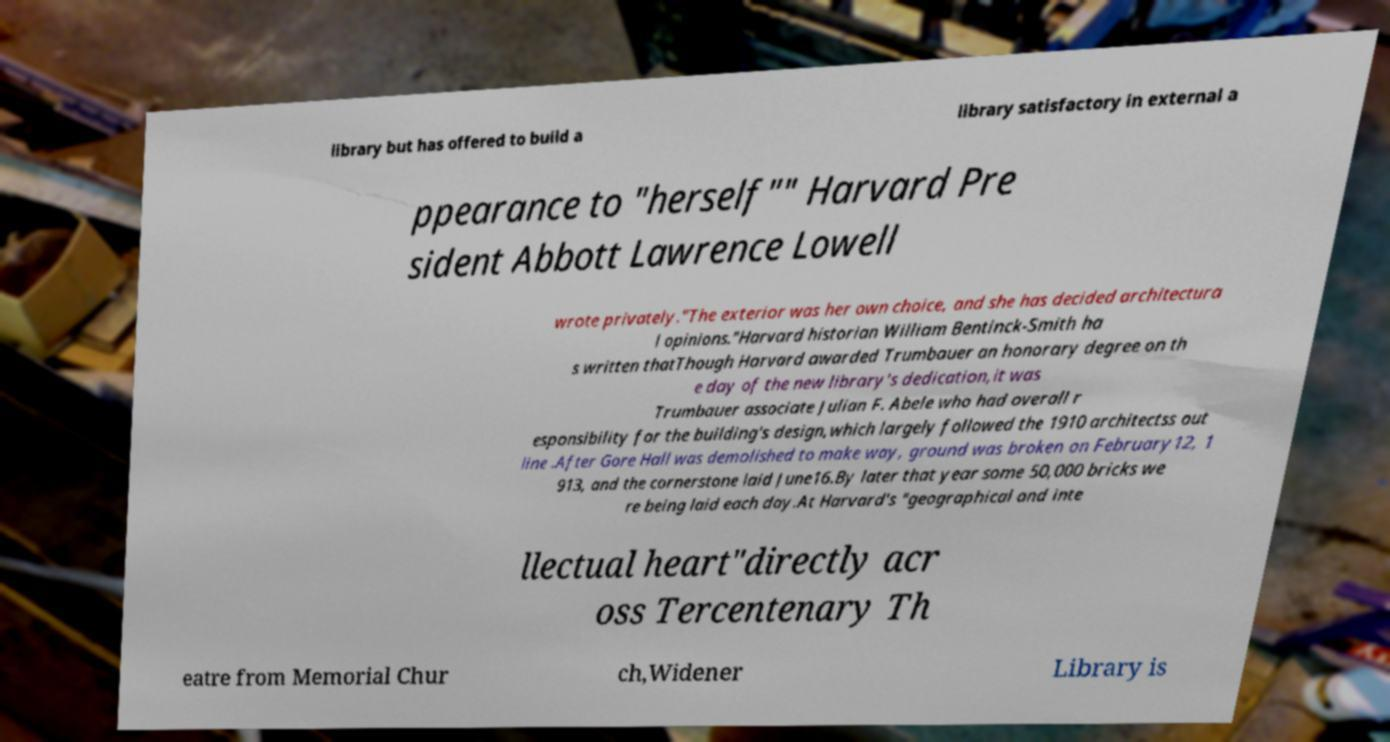Please identify and transcribe the text found in this image. library but has offered to build a library satisfactory in external a ppearance to "herself"" Harvard Pre sident Abbott Lawrence Lowell wrote privately."The exterior was her own choice, and she has decided architectura l opinions."Harvard historian William Bentinck-Smith ha s written thatThough Harvard awarded Trumbauer an honorary degree on th e day of the new library's dedication,it was Trumbauer associate Julian F. Abele who had overall r esponsibility for the building's design,which largely followed the 1910 architectss out line .After Gore Hall was demolished to make way, ground was broken on February12, 1 913, and the cornerstone laid June16.By later that year some 50,000 bricks we re being laid each day.At Harvard's "geographical and inte llectual heart"directly acr oss Tercentenary Th eatre from Memorial Chur ch,Widener Library is 